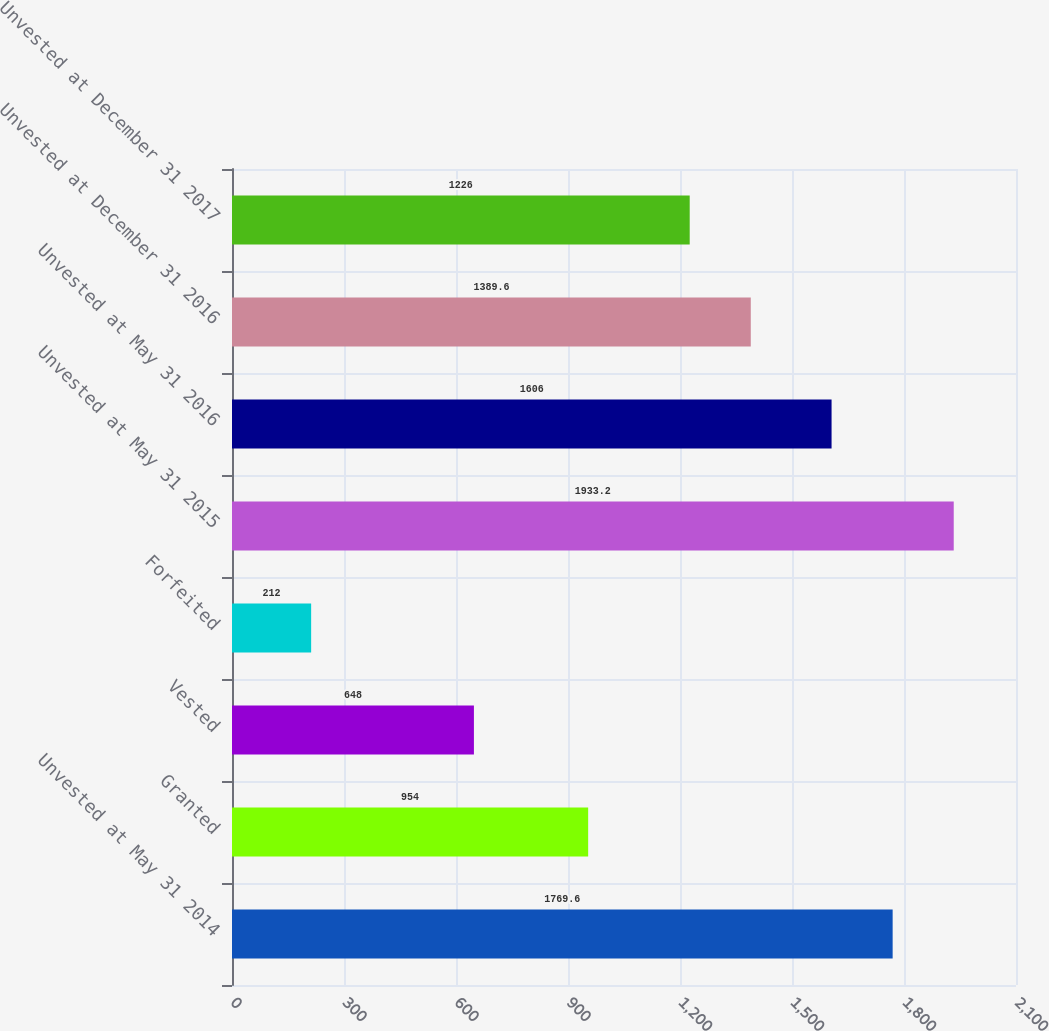Convert chart. <chart><loc_0><loc_0><loc_500><loc_500><bar_chart><fcel>Unvested at May 31 2014<fcel>Granted<fcel>Vested<fcel>Forfeited<fcel>Unvested at May 31 2015<fcel>Unvested at May 31 2016<fcel>Unvested at December 31 2016<fcel>Unvested at December 31 2017<nl><fcel>1769.6<fcel>954<fcel>648<fcel>212<fcel>1933.2<fcel>1606<fcel>1389.6<fcel>1226<nl></chart> 